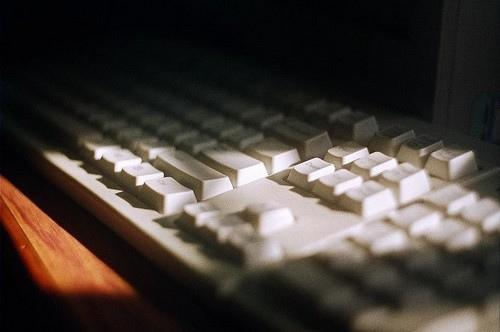What color are the keys?
Short answer required. White. Is this keyboard disassembled?
Write a very short answer. No. Is the computer working?
Give a very brief answer. Yes. Is the keyboard new?
Quick response, please. Yes. Is this keyboard clean?
Be succinct. Yes. 